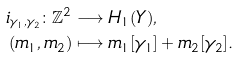<formula> <loc_0><loc_0><loc_500><loc_500>i _ { \gamma _ { 1 } , \gamma _ { 2 } } \colon \mathbb { Z } ^ { 2 } & \longrightarrow H _ { 1 } ( Y ) , \\ ( m _ { 1 } , m _ { 2 } ) & \longmapsto m _ { 1 } [ \gamma _ { 1 } ] + m _ { 2 } [ \gamma _ { 2 } ] .</formula> 